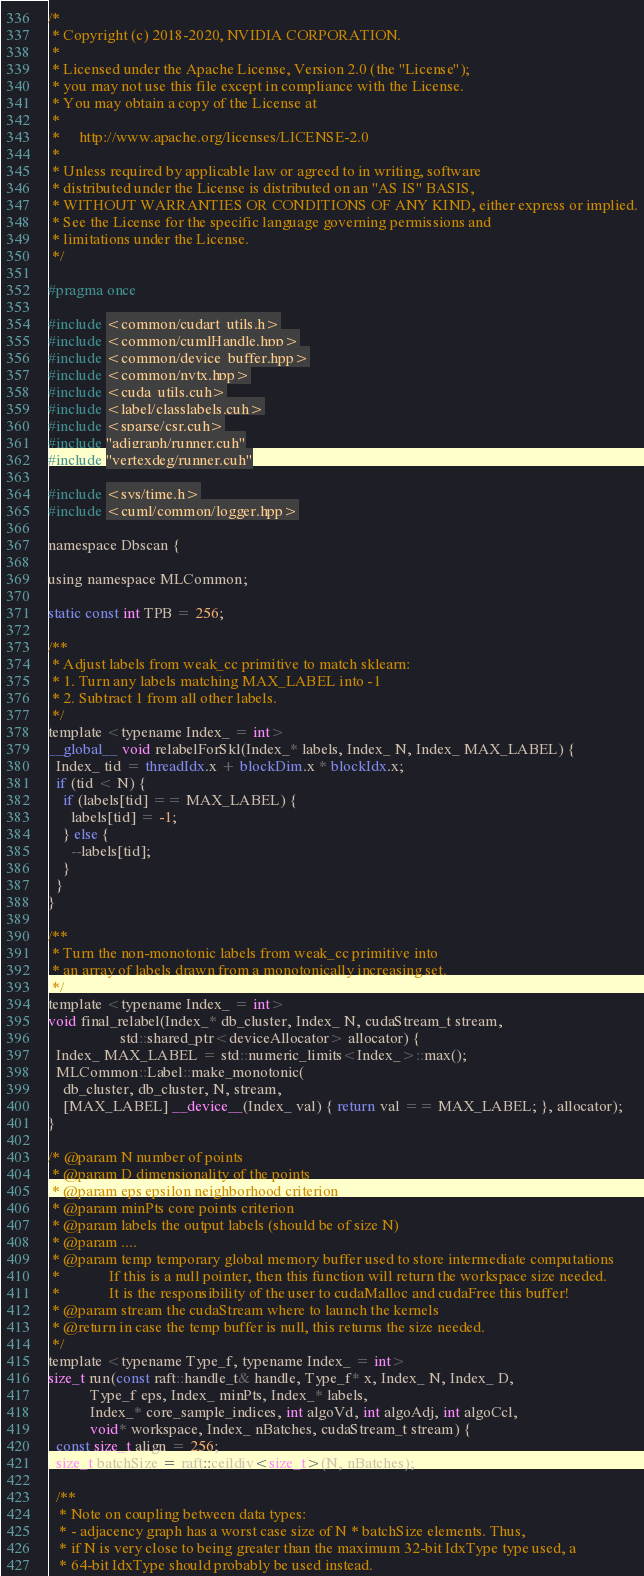<code> <loc_0><loc_0><loc_500><loc_500><_Cuda_>/*
 * Copyright (c) 2018-2020, NVIDIA CORPORATION.
 *
 * Licensed under the Apache License, Version 2.0 (the "License");
 * you may not use this file except in compliance with the License.
 * You may obtain a copy of the License at
 *
 *     http://www.apache.org/licenses/LICENSE-2.0
 *
 * Unless required by applicable law or agreed to in writing, software
 * distributed under the License is distributed on an "AS IS" BASIS,
 * WITHOUT WARRANTIES OR CONDITIONS OF ANY KIND, either express or implied.
 * See the License for the specific language governing permissions and
 * limitations under the License.
 */

#pragma once

#include <common/cudart_utils.h>
#include <common/cumlHandle.hpp>
#include <common/device_buffer.hpp>
#include <common/nvtx.hpp>
#include <cuda_utils.cuh>
#include <label/classlabels.cuh>
#include <sparse/csr.cuh>
#include "adjgraph/runner.cuh"
#include "vertexdeg/runner.cuh"

#include <sys/time.h>
#include <cuml/common/logger.hpp>

namespace Dbscan {

using namespace MLCommon;

static const int TPB = 256;

/**
 * Adjust labels from weak_cc primitive to match sklearn:
 * 1. Turn any labels matching MAX_LABEL into -1
 * 2. Subtract 1 from all other labels.
 */
template <typename Index_ = int>
__global__ void relabelForSkl(Index_* labels, Index_ N, Index_ MAX_LABEL) {
  Index_ tid = threadIdx.x + blockDim.x * blockIdx.x;
  if (tid < N) {
    if (labels[tid] == MAX_LABEL) {
      labels[tid] = -1;
    } else {
      --labels[tid];
    }
  }
}

/**
 * Turn the non-monotonic labels from weak_cc primitive into
 * an array of labels drawn from a monotonically increasing set.
 */
template <typename Index_ = int>
void final_relabel(Index_* db_cluster, Index_ N, cudaStream_t stream,
                   std::shared_ptr<deviceAllocator> allocator) {
  Index_ MAX_LABEL = std::numeric_limits<Index_>::max();
  MLCommon::Label::make_monotonic(
    db_cluster, db_cluster, N, stream,
    [MAX_LABEL] __device__(Index_ val) { return val == MAX_LABEL; }, allocator);
}

/* @param N number of points
 * @param D dimensionality of the points
 * @param eps epsilon neighborhood criterion
 * @param minPts core points criterion
 * @param labels the output labels (should be of size N)
 * @param ....
 * @param temp temporary global memory buffer used to store intermediate computations
 *             If this is a null pointer, then this function will return the workspace size needed.
 *             It is the responsibility of the user to cudaMalloc and cudaFree this buffer!
 * @param stream the cudaStream where to launch the kernels
 * @return in case the temp buffer is null, this returns the size needed.
 */
template <typename Type_f, typename Index_ = int>
size_t run(const raft::handle_t& handle, Type_f* x, Index_ N, Index_ D,
           Type_f eps, Index_ minPts, Index_* labels,
           Index_* core_sample_indices, int algoVd, int algoAdj, int algoCcl,
           void* workspace, Index_ nBatches, cudaStream_t stream) {
  const size_t align = 256;
  size_t batchSize = raft::ceildiv<size_t>(N, nBatches);

  /**
   * Note on coupling between data types:
   * - adjacency graph has a worst case size of N * batchSize elements. Thus,
   * if N is very close to being greater than the maximum 32-bit IdxType type used, a
   * 64-bit IdxType should probably be used instead.</code> 